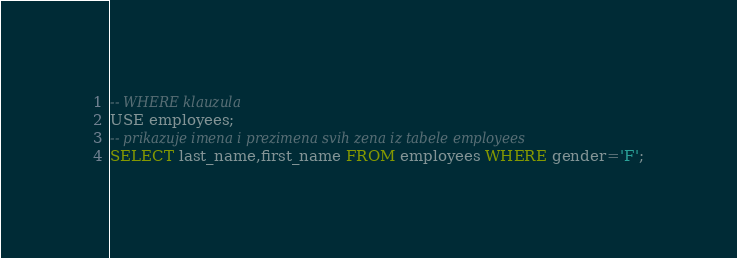<code> <loc_0><loc_0><loc_500><loc_500><_SQL_>-- WHERE klauzula
USE employees;
-- prikazuje imena i prezimena svih zena iz tabele employees
SELECT last_name,first_name FROM employees WHERE gender='F';</code> 